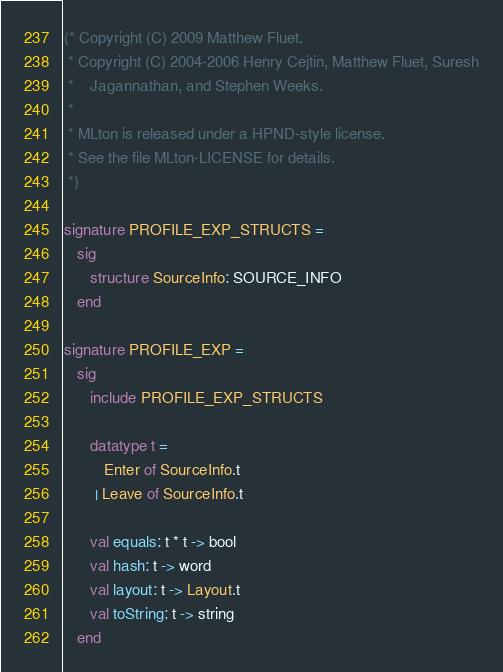<code> <loc_0><loc_0><loc_500><loc_500><_SML_>(* Copyright (C) 2009 Matthew Fluet.
 * Copyright (C) 2004-2006 Henry Cejtin, Matthew Fluet, Suresh
 *    Jagannathan, and Stephen Weeks.
 *
 * MLton is released under a HPND-style license.
 * See the file MLton-LICENSE for details.
 *)

signature PROFILE_EXP_STRUCTS =
   sig
      structure SourceInfo: SOURCE_INFO
   end

signature PROFILE_EXP =
   sig
      include PROFILE_EXP_STRUCTS

      datatype t =
         Enter of SourceInfo.t
       | Leave of SourceInfo.t

      val equals: t * t -> bool
      val hash: t -> word
      val layout: t -> Layout.t
      val toString: t -> string
   end
</code> 